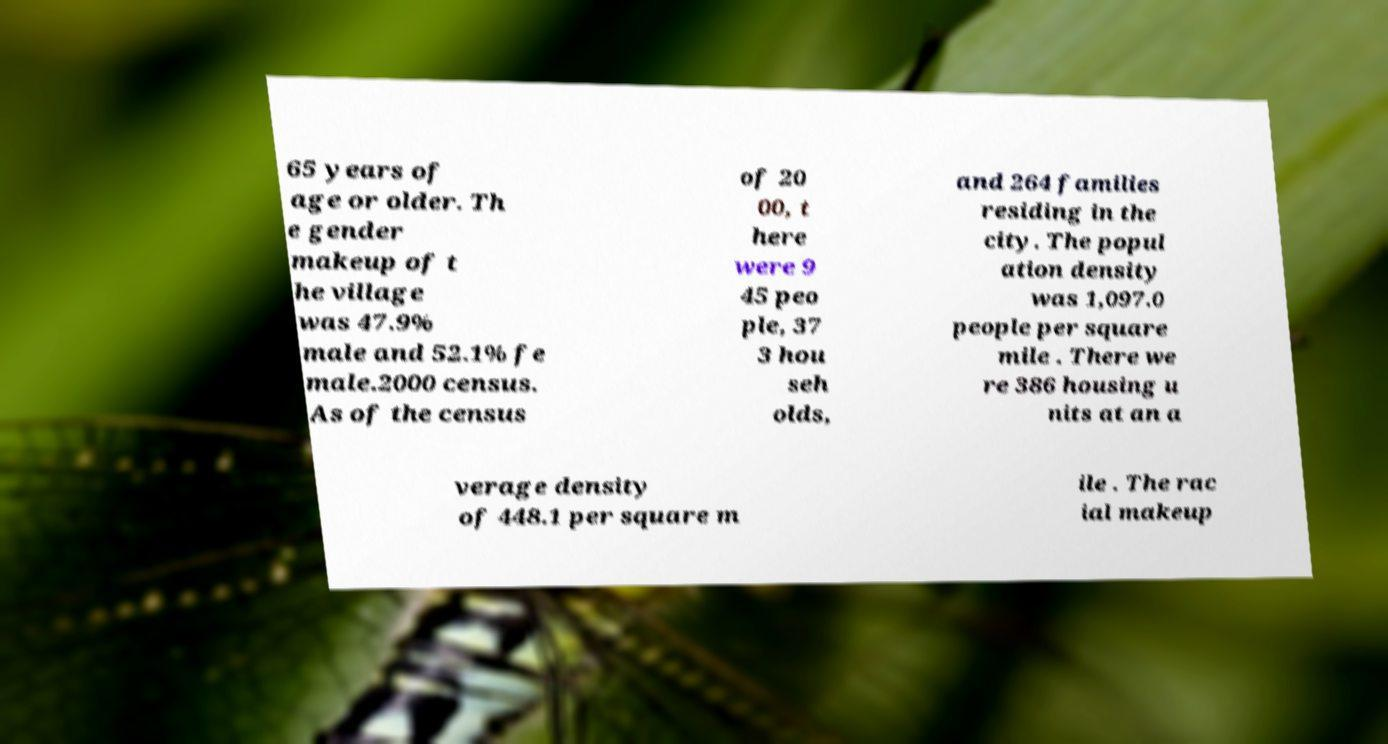For documentation purposes, I need the text within this image transcribed. Could you provide that? 65 years of age or older. Th e gender makeup of t he village was 47.9% male and 52.1% fe male.2000 census. As of the census of 20 00, t here were 9 45 peo ple, 37 3 hou seh olds, and 264 families residing in the city. The popul ation density was 1,097.0 people per square mile . There we re 386 housing u nits at an a verage density of 448.1 per square m ile . The rac ial makeup 